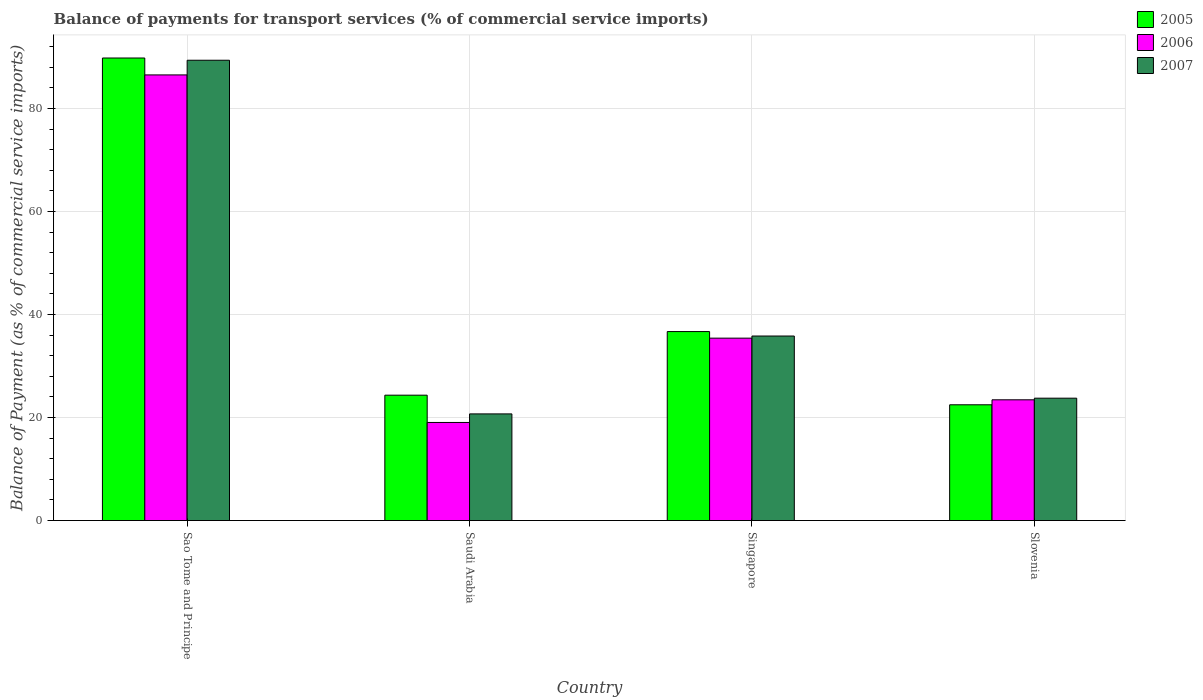How many different coloured bars are there?
Make the answer very short. 3. How many groups of bars are there?
Provide a succinct answer. 4. Are the number of bars per tick equal to the number of legend labels?
Your answer should be compact. Yes. Are the number of bars on each tick of the X-axis equal?
Provide a succinct answer. Yes. How many bars are there on the 2nd tick from the right?
Offer a very short reply. 3. What is the label of the 4th group of bars from the left?
Your answer should be very brief. Slovenia. In how many cases, is the number of bars for a given country not equal to the number of legend labels?
Provide a succinct answer. 0. What is the balance of payments for transport services in 2006 in Sao Tome and Principe?
Ensure brevity in your answer.  86.52. Across all countries, what is the maximum balance of payments for transport services in 2006?
Your response must be concise. 86.52. Across all countries, what is the minimum balance of payments for transport services in 2005?
Your answer should be compact. 22.48. In which country was the balance of payments for transport services in 2005 maximum?
Keep it short and to the point. Sao Tome and Principe. In which country was the balance of payments for transport services in 2006 minimum?
Your answer should be compact. Saudi Arabia. What is the total balance of payments for transport services in 2007 in the graph?
Your answer should be very brief. 169.67. What is the difference between the balance of payments for transport services in 2007 in Sao Tome and Principe and that in Slovenia?
Your answer should be very brief. 65.61. What is the difference between the balance of payments for transport services in 2006 in Saudi Arabia and the balance of payments for transport services in 2007 in Slovenia?
Give a very brief answer. -4.71. What is the average balance of payments for transport services in 2007 per country?
Keep it short and to the point. 42.42. What is the difference between the balance of payments for transport services of/in 2007 and balance of payments for transport services of/in 2005 in Sao Tome and Principe?
Provide a succinct answer. -0.43. In how many countries, is the balance of payments for transport services in 2007 greater than 48 %?
Keep it short and to the point. 1. What is the ratio of the balance of payments for transport services in 2005 in Sao Tome and Principe to that in Singapore?
Make the answer very short. 2.45. Is the balance of payments for transport services in 2005 in Sao Tome and Principe less than that in Saudi Arabia?
Make the answer very short. No. Is the difference between the balance of payments for transport services in 2007 in Saudi Arabia and Slovenia greater than the difference between the balance of payments for transport services in 2005 in Saudi Arabia and Slovenia?
Provide a short and direct response. No. What is the difference between the highest and the second highest balance of payments for transport services in 2005?
Give a very brief answer. -65.46. What is the difference between the highest and the lowest balance of payments for transport services in 2006?
Provide a short and direct response. 67.47. Is the sum of the balance of payments for transport services in 2007 in Sao Tome and Principe and Singapore greater than the maximum balance of payments for transport services in 2006 across all countries?
Your answer should be very brief. Yes. What does the 1st bar from the left in Saudi Arabia represents?
Provide a short and direct response. 2005. What does the 1st bar from the right in Sao Tome and Principe represents?
Offer a terse response. 2007. How many bars are there?
Offer a terse response. 12. How many countries are there in the graph?
Your answer should be very brief. 4. What is the difference between two consecutive major ticks on the Y-axis?
Keep it short and to the point. 20. Does the graph contain any zero values?
Provide a short and direct response. No. Where does the legend appear in the graph?
Your answer should be compact. Top right. How many legend labels are there?
Offer a very short reply. 3. How are the legend labels stacked?
Make the answer very short. Vertical. What is the title of the graph?
Make the answer very short. Balance of payments for transport services (% of commercial service imports). What is the label or title of the X-axis?
Provide a succinct answer. Country. What is the label or title of the Y-axis?
Provide a short and direct response. Balance of Payment (as % of commercial service imports). What is the Balance of Payment (as % of commercial service imports) in 2005 in Sao Tome and Principe?
Provide a short and direct response. 89.8. What is the Balance of Payment (as % of commercial service imports) of 2006 in Sao Tome and Principe?
Offer a terse response. 86.52. What is the Balance of Payment (as % of commercial service imports) of 2007 in Sao Tome and Principe?
Provide a succinct answer. 89.37. What is the Balance of Payment (as % of commercial service imports) in 2005 in Saudi Arabia?
Offer a terse response. 24.34. What is the Balance of Payment (as % of commercial service imports) of 2006 in Saudi Arabia?
Give a very brief answer. 19.05. What is the Balance of Payment (as % of commercial service imports) of 2007 in Saudi Arabia?
Offer a very short reply. 20.71. What is the Balance of Payment (as % of commercial service imports) in 2005 in Singapore?
Keep it short and to the point. 36.69. What is the Balance of Payment (as % of commercial service imports) in 2006 in Singapore?
Provide a succinct answer. 35.42. What is the Balance of Payment (as % of commercial service imports) in 2007 in Singapore?
Your answer should be compact. 35.83. What is the Balance of Payment (as % of commercial service imports) of 2005 in Slovenia?
Provide a succinct answer. 22.48. What is the Balance of Payment (as % of commercial service imports) of 2006 in Slovenia?
Make the answer very short. 23.45. What is the Balance of Payment (as % of commercial service imports) of 2007 in Slovenia?
Ensure brevity in your answer.  23.76. Across all countries, what is the maximum Balance of Payment (as % of commercial service imports) in 2005?
Offer a terse response. 89.8. Across all countries, what is the maximum Balance of Payment (as % of commercial service imports) of 2006?
Provide a short and direct response. 86.52. Across all countries, what is the maximum Balance of Payment (as % of commercial service imports) of 2007?
Your answer should be very brief. 89.37. Across all countries, what is the minimum Balance of Payment (as % of commercial service imports) of 2005?
Your answer should be compact. 22.48. Across all countries, what is the minimum Balance of Payment (as % of commercial service imports) of 2006?
Ensure brevity in your answer.  19.05. Across all countries, what is the minimum Balance of Payment (as % of commercial service imports) in 2007?
Offer a very short reply. 20.71. What is the total Balance of Payment (as % of commercial service imports) in 2005 in the graph?
Give a very brief answer. 173.32. What is the total Balance of Payment (as % of commercial service imports) in 2006 in the graph?
Provide a short and direct response. 164.43. What is the total Balance of Payment (as % of commercial service imports) of 2007 in the graph?
Keep it short and to the point. 169.67. What is the difference between the Balance of Payment (as % of commercial service imports) of 2005 in Sao Tome and Principe and that in Saudi Arabia?
Make the answer very short. 65.46. What is the difference between the Balance of Payment (as % of commercial service imports) in 2006 in Sao Tome and Principe and that in Saudi Arabia?
Your response must be concise. 67.47. What is the difference between the Balance of Payment (as % of commercial service imports) of 2007 in Sao Tome and Principe and that in Saudi Arabia?
Your response must be concise. 68.66. What is the difference between the Balance of Payment (as % of commercial service imports) in 2005 in Sao Tome and Principe and that in Singapore?
Your answer should be compact. 53.11. What is the difference between the Balance of Payment (as % of commercial service imports) of 2006 in Sao Tome and Principe and that in Singapore?
Give a very brief answer. 51.1. What is the difference between the Balance of Payment (as % of commercial service imports) in 2007 in Sao Tome and Principe and that in Singapore?
Offer a terse response. 53.54. What is the difference between the Balance of Payment (as % of commercial service imports) of 2005 in Sao Tome and Principe and that in Slovenia?
Keep it short and to the point. 67.32. What is the difference between the Balance of Payment (as % of commercial service imports) of 2006 in Sao Tome and Principe and that in Slovenia?
Give a very brief answer. 63.07. What is the difference between the Balance of Payment (as % of commercial service imports) of 2007 in Sao Tome and Principe and that in Slovenia?
Provide a succinct answer. 65.61. What is the difference between the Balance of Payment (as % of commercial service imports) in 2005 in Saudi Arabia and that in Singapore?
Offer a very short reply. -12.35. What is the difference between the Balance of Payment (as % of commercial service imports) in 2006 in Saudi Arabia and that in Singapore?
Your answer should be very brief. -16.37. What is the difference between the Balance of Payment (as % of commercial service imports) in 2007 in Saudi Arabia and that in Singapore?
Provide a short and direct response. -15.12. What is the difference between the Balance of Payment (as % of commercial service imports) of 2005 in Saudi Arabia and that in Slovenia?
Keep it short and to the point. 1.86. What is the difference between the Balance of Payment (as % of commercial service imports) of 2006 in Saudi Arabia and that in Slovenia?
Provide a succinct answer. -4.4. What is the difference between the Balance of Payment (as % of commercial service imports) of 2007 in Saudi Arabia and that in Slovenia?
Your answer should be very brief. -3.05. What is the difference between the Balance of Payment (as % of commercial service imports) of 2005 in Singapore and that in Slovenia?
Offer a terse response. 14.21. What is the difference between the Balance of Payment (as % of commercial service imports) in 2006 in Singapore and that in Slovenia?
Offer a terse response. 11.97. What is the difference between the Balance of Payment (as % of commercial service imports) of 2007 in Singapore and that in Slovenia?
Make the answer very short. 12.07. What is the difference between the Balance of Payment (as % of commercial service imports) in 2005 in Sao Tome and Principe and the Balance of Payment (as % of commercial service imports) in 2006 in Saudi Arabia?
Your answer should be very brief. 70.75. What is the difference between the Balance of Payment (as % of commercial service imports) of 2005 in Sao Tome and Principe and the Balance of Payment (as % of commercial service imports) of 2007 in Saudi Arabia?
Your response must be concise. 69.09. What is the difference between the Balance of Payment (as % of commercial service imports) of 2006 in Sao Tome and Principe and the Balance of Payment (as % of commercial service imports) of 2007 in Saudi Arabia?
Give a very brief answer. 65.81. What is the difference between the Balance of Payment (as % of commercial service imports) of 2005 in Sao Tome and Principe and the Balance of Payment (as % of commercial service imports) of 2006 in Singapore?
Provide a succinct answer. 54.39. What is the difference between the Balance of Payment (as % of commercial service imports) of 2005 in Sao Tome and Principe and the Balance of Payment (as % of commercial service imports) of 2007 in Singapore?
Provide a succinct answer. 53.97. What is the difference between the Balance of Payment (as % of commercial service imports) of 2006 in Sao Tome and Principe and the Balance of Payment (as % of commercial service imports) of 2007 in Singapore?
Ensure brevity in your answer.  50.69. What is the difference between the Balance of Payment (as % of commercial service imports) of 2005 in Sao Tome and Principe and the Balance of Payment (as % of commercial service imports) of 2006 in Slovenia?
Ensure brevity in your answer.  66.36. What is the difference between the Balance of Payment (as % of commercial service imports) of 2005 in Sao Tome and Principe and the Balance of Payment (as % of commercial service imports) of 2007 in Slovenia?
Ensure brevity in your answer.  66.04. What is the difference between the Balance of Payment (as % of commercial service imports) in 2006 in Sao Tome and Principe and the Balance of Payment (as % of commercial service imports) in 2007 in Slovenia?
Your answer should be compact. 62.76. What is the difference between the Balance of Payment (as % of commercial service imports) in 2005 in Saudi Arabia and the Balance of Payment (as % of commercial service imports) in 2006 in Singapore?
Your answer should be compact. -11.07. What is the difference between the Balance of Payment (as % of commercial service imports) of 2005 in Saudi Arabia and the Balance of Payment (as % of commercial service imports) of 2007 in Singapore?
Make the answer very short. -11.49. What is the difference between the Balance of Payment (as % of commercial service imports) in 2006 in Saudi Arabia and the Balance of Payment (as % of commercial service imports) in 2007 in Singapore?
Provide a short and direct response. -16.78. What is the difference between the Balance of Payment (as % of commercial service imports) in 2005 in Saudi Arabia and the Balance of Payment (as % of commercial service imports) in 2006 in Slovenia?
Provide a short and direct response. 0.9. What is the difference between the Balance of Payment (as % of commercial service imports) in 2005 in Saudi Arabia and the Balance of Payment (as % of commercial service imports) in 2007 in Slovenia?
Your answer should be very brief. 0.58. What is the difference between the Balance of Payment (as % of commercial service imports) of 2006 in Saudi Arabia and the Balance of Payment (as % of commercial service imports) of 2007 in Slovenia?
Ensure brevity in your answer.  -4.71. What is the difference between the Balance of Payment (as % of commercial service imports) of 2005 in Singapore and the Balance of Payment (as % of commercial service imports) of 2006 in Slovenia?
Give a very brief answer. 13.25. What is the difference between the Balance of Payment (as % of commercial service imports) in 2005 in Singapore and the Balance of Payment (as % of commercial service imports) in 2007 in Slovenia?
Give a very brief answer. 12.93. What is the difference between the Balance of Payment (as % of commercial service imports) of 2006 in Singapore and the Balance of Payment (as % of commercial service imports) of 2007 in Slovenia?
Offer a terse response. 11.66. What is the average Balance of Payment (as % of commercial service imports) in 2005 per country?
Give a very brief answer. 43.33. What is the average Balance of Payment (as % of commercial service imports) of 2006 per country?
Offer a very short reply. 41.11. What is the average Balance of Payment (as % of commercial service imports) of 2007 per country?
Provide a short and direct response. 42.42. What is the difference between the Balance of Payment (as % of commercial service imports) of 2005 and Balance of Payment (as % of commercial service imports) of 2006 in Sao Tome and Principe?
Provide a short and direct response. 3.28. What is the difference between the Balance of Payment (as % of commercial service imports) in 2005 and Balance of Payment (as % of commercial service imports) in 2007 in Sao Tome and Principe?
Your response must be concise. 0.43. What is the difference between the Balance of Payment (as % of commercial service imports) in 2006 and Balance of Payment (as % of commercial service imports) in 2007 in Sao Tome and Principe?
Keep it short and to the point. -2.85. What is the difference between the Balance of Payment (as % of commercial service imports) in 2005 and Balance of Payment (as % of commercial service imports) in 2006 in Saudi Arabia?
Give a very brief answer. 5.29. What is the difference between the Balance of Payment (as % of commercial service imports) of 2005 and Balance of Payment (as % of commercial service imports) of 2007 in Saudi Arabia?
Ensure brevity in your answer.  3.63. What is the difference between the Balance of Payment (as % of commercial service imports) of 2006 and Balance of Payment (as % of commercial service imports) of 2007 in Saudi Arabia?
Provide a succinct answer. -1.66. What is the difference between the Balance of Payment (as % of commercial service imports) of 2005 and Balance of Payment (as % of commercial service imports) of 2006 in Singapore?
Offer a terse response. 1.28. What is the difference between the Balance of Payment (as % of commercial service imports) in 2005 and Balance of Payment (as % of commercial service imports) in 2007 in Singapore?
Give a very brief answer. 0.86. What is the difference between the Balance of Payment (as % of commercial service imports) in 2006 and Balance of Payment (as % of commercial service imports) in 2007 in Singapore?
Offer a terse response. -0.41. What is the difference between the Balance of Payment (as % of commercial service imports) in 2005 and Balance of Payment (as % of commercial service imports) in 2006 in Slovenia?
Make the answer very short. -0.97. What is the difference between the Balance of Payment (as % of commercial service imports) in 2005 and Balance of Payment (as % of commercial service imports) in 2007 in Slovenia?
Offer a terse response. -1.28. What is the difference between the Balance of Payment (as % of commercial service imports) in 2006 and Balance of Payment (as % of commercial service imports) in 2007 in Slovenia?
Offer a terse response. -0.31. What is the ratio of the Balance of Payment (as % of commercial service imports) in 2005 in Sao Tome and Principe to that in Saudi Arabia?
Keep it short and to the point. 3.69. What is the ratio of the Balance of Payment (as % of commercial service imports) in 2006 in Sao Tome and Principe to that in Saudi Arabia?
Your answer should be very brief. 4.54. What is the ratio of the Balance of Payment (as % of commercial service imports) in 2007 in Sao Tome and Principe to that in Saudi Arabia?
Your response must be concise. 4.32. What is the ratio of the Balance of Payment (as % of commercial service imports) in 2005 in Sao Tome and Principe to that in Singapore?
Your answer should be very brief. 2.45. What is the ratio of the Balance of Payment (as % of commercial service imports) of 2006 in Sao Tome and Principe to that in Singapore?
Ensure brevity in your answer.  2.44. What is the ratio of the Balance of Payment (as % of commercial service imports) of 2007 in Sao Tome and Principe to that in Singapore?
Ensure brevity in your answer.  2.49. What is the ratio of the Balance of Payment (as % of commercial service imports) in 2005 in Sao Tome and Principe to that in Slovenia?
Keep it short and to the point. 3.99. What is the ratio of the Balance of Payment (as % of commercial service imports) of 2006 in Sao Tome and Principe to that in Slovenia?
Your response must be concise. 3.69. What is the ratio of the Balance of Payment (as % of commercial service imports) of 2007 in Sao Tome and Principe to that in Slovenia?
Your answer should be compact. 3.76. What is the ratio of the Balance of Payment (as % of commercial service imports) of 2005 in Saudi Arabia to that in Singapore?
Your response must be concise. 0.66. What is the ratio of the Balance of Payment (as % of commercial service imports) in 2006 in Saudi Arabia to that in Singapore?
Provide a short and direct response. 0.54. What is the ratio of the Balance of Payment (as % of commercial service imports) of 2007 in Saudi Arabia to that in Singapore?
Your answer should be very brief. 0.58. What is the ratio of the Balance of Payment (as % of commercial service imports) in 2005 in Saudi Arabia to that in Slovenia?
Your answer should be compact. 1.08. What is the ratio of the Balance of Payment (as % of commercial service imports) in 2006 in Saudi Arabia to that in Slovenia?
Your response must be concise. 0.81. What is the ratio of the Balance of Payment (as % of commercial service imports) in 2007 in Saudi Arabia to that in Slovenia?
Ensure brevity in your answer.  0.87. What is the ratio of the Balance of Payment (as % of commercial service imports) of 2005 in Singapore to that in Slovenia?
Provide a succinct answer. 1.63. What is the ratio of the Balance of Payment (as % of commercial service imports) in 2006 in Singapore to that in Slovenia?
Provide a succinct answer. 1.51. What is the ratio of the Balance of Payment (as % of commercial service imports) in 2007 in Singapore to that in Slovenia?
Ensure brevity in your answer.  1.51. What is the difference between the highest and the second highest Balance of Payment (as % of commercial service imports) of 2005?
Provide a succinct answer. 53.11. What is the difference between the highest and the second highest Balance of Payment (as % of commercial service imports) of 2006?
Ensure brevity in your answer.  51.1. What is the difference between the highest and the second highest Balance of Payment (as % of commercial service imports) in 2007?
Offer a very short reply. 53.54. What is the difference between the highest and the lowest Balance of Payment (as % of commercial service imports) in 2005?
Offer a very short reply. 67.32. What is the difference between the highest and the lowest Balance of Payment (as % of commercial service imports) of 2006?
Provide a succinct answer. 67.47. What is the difference between the highest and the lowest Balance of Payment (as % of commercial service imports) in 2007?
Your answer should be compact. 68.66. 